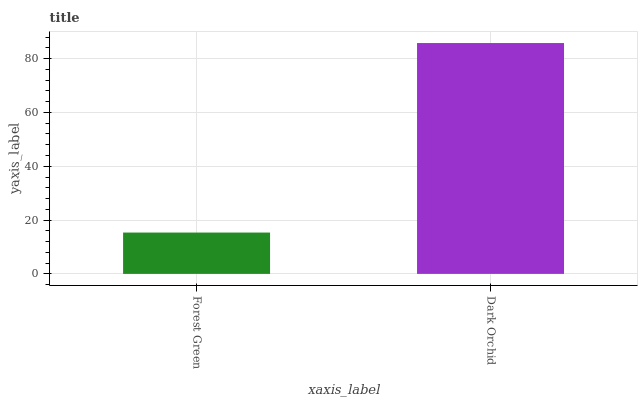Is Forest Green the minimum?
Answer yes or no. Yes. Is Dark Orchid the maximum?
Answer yes or no. Yes. Is Dark Orchid the minimum?
Answer yes or no. No. Is Dark Orchid greater than Forest Green?
Answer yes or no. Yes. Is Forest Green less than Dark Orchid?
Answer yes or no. Yes. Is Forest Green greater than Dark Orchid?
Answer yes or no. No. Is Dark Orchid less than Forest Green?
Answer yes or no. No. Is Dark Orchid the high median?
Answer yes or no. Yes. Is Forest Green the low median?
Answer yes or no. Yes. Is Forest Green the high median?
Answer yes or no. No. Is Dark Orchid the low median?
Answer yes or no. No. 